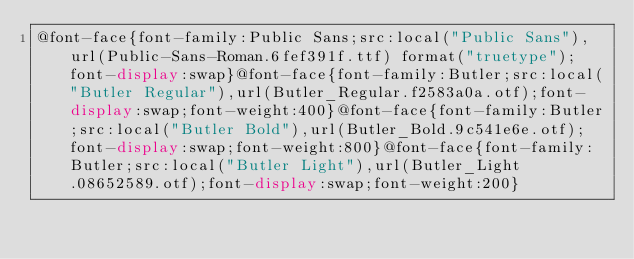Convert code to text. <code><loc_0><loc_0><loc_500><loc_500><_CSS_>@font-face{font-family:Public Sans;src:local("Public Sans"),url(Public-Sans-Roman.6fef391f.ttf) format("truetype");font-display:swap}@font-face{font-family:Butler;src:local("Butler Regular"),url(Butler_Regular.f2583a0a.otf);font-display:swap;font-weight:400}@font-face{font-family:Butler;src:local("Butler Bold"),url(Butler_Bold.9c541e6e.otf);font-display:swap;font-weight:800}@font-face{font-family:Butler;src:local("Butler Light"),url(Butler_Light.08652589.otf);font-display:swap;font-weight:200}</code> 